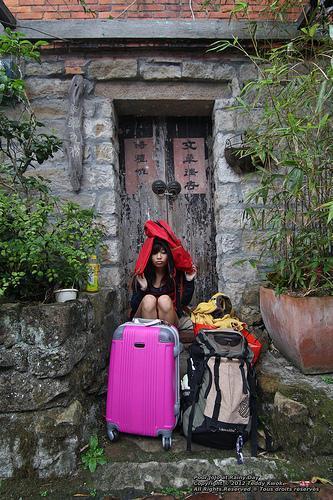How many people are pictured?
Give a very brief answer. 1. 